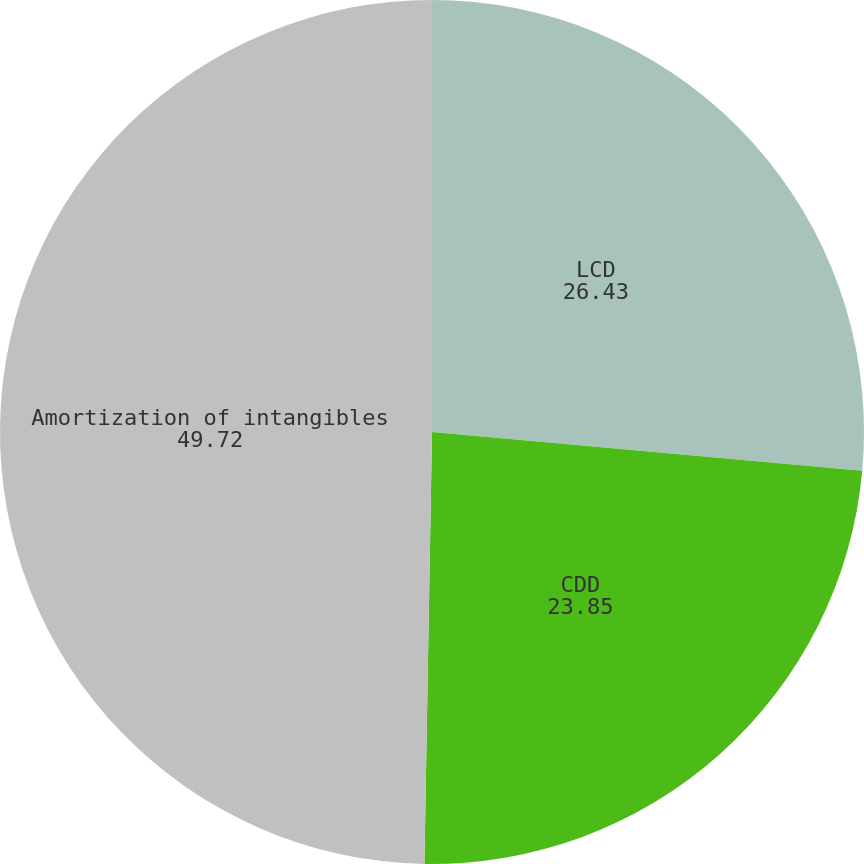<chart> <loc_0><loc_0><loc_500><loc_500><pie_chart><fcel>LCD<fcel>CDD<fcel>Amortization of intangibles<nl><fcel>26.43%<fcel>23.85%<fcel>49.72%<nl></chart> 